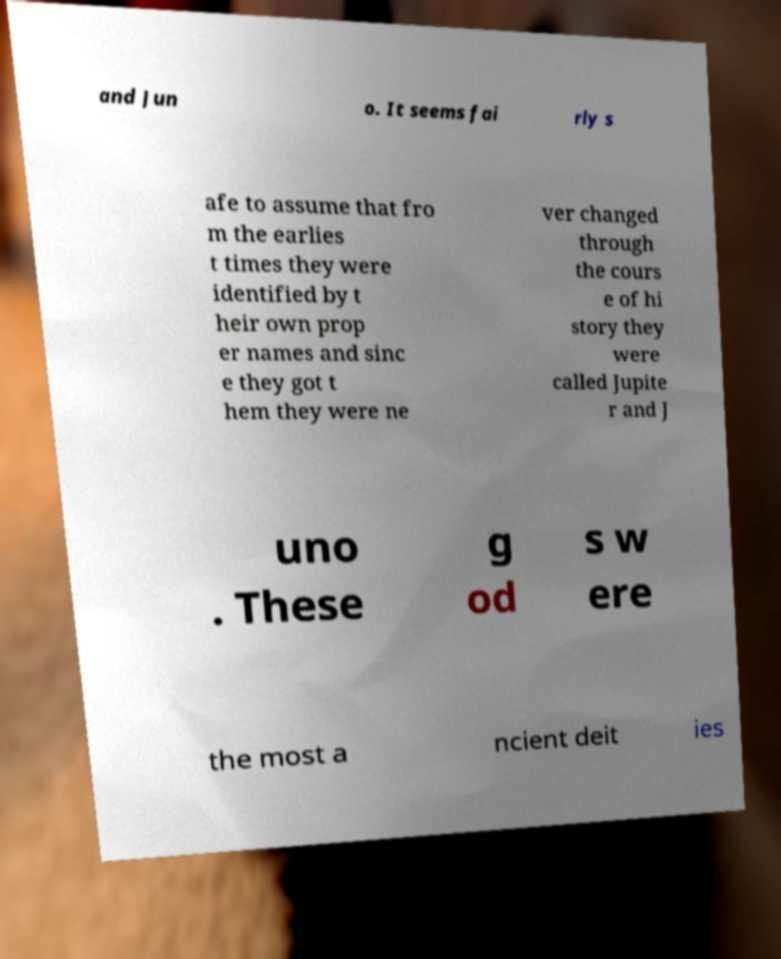Please identify and transcribe the text found in this image. and Jun o. It seems fai rly s afe to assume that fro m the earlies t times they were identified by t heir own prop er names and sinc e they got t hem they were ne ver changed through the cours e of hi story they were called Jupite r and J uno . These g od s w ere the most a ncient deit ies 